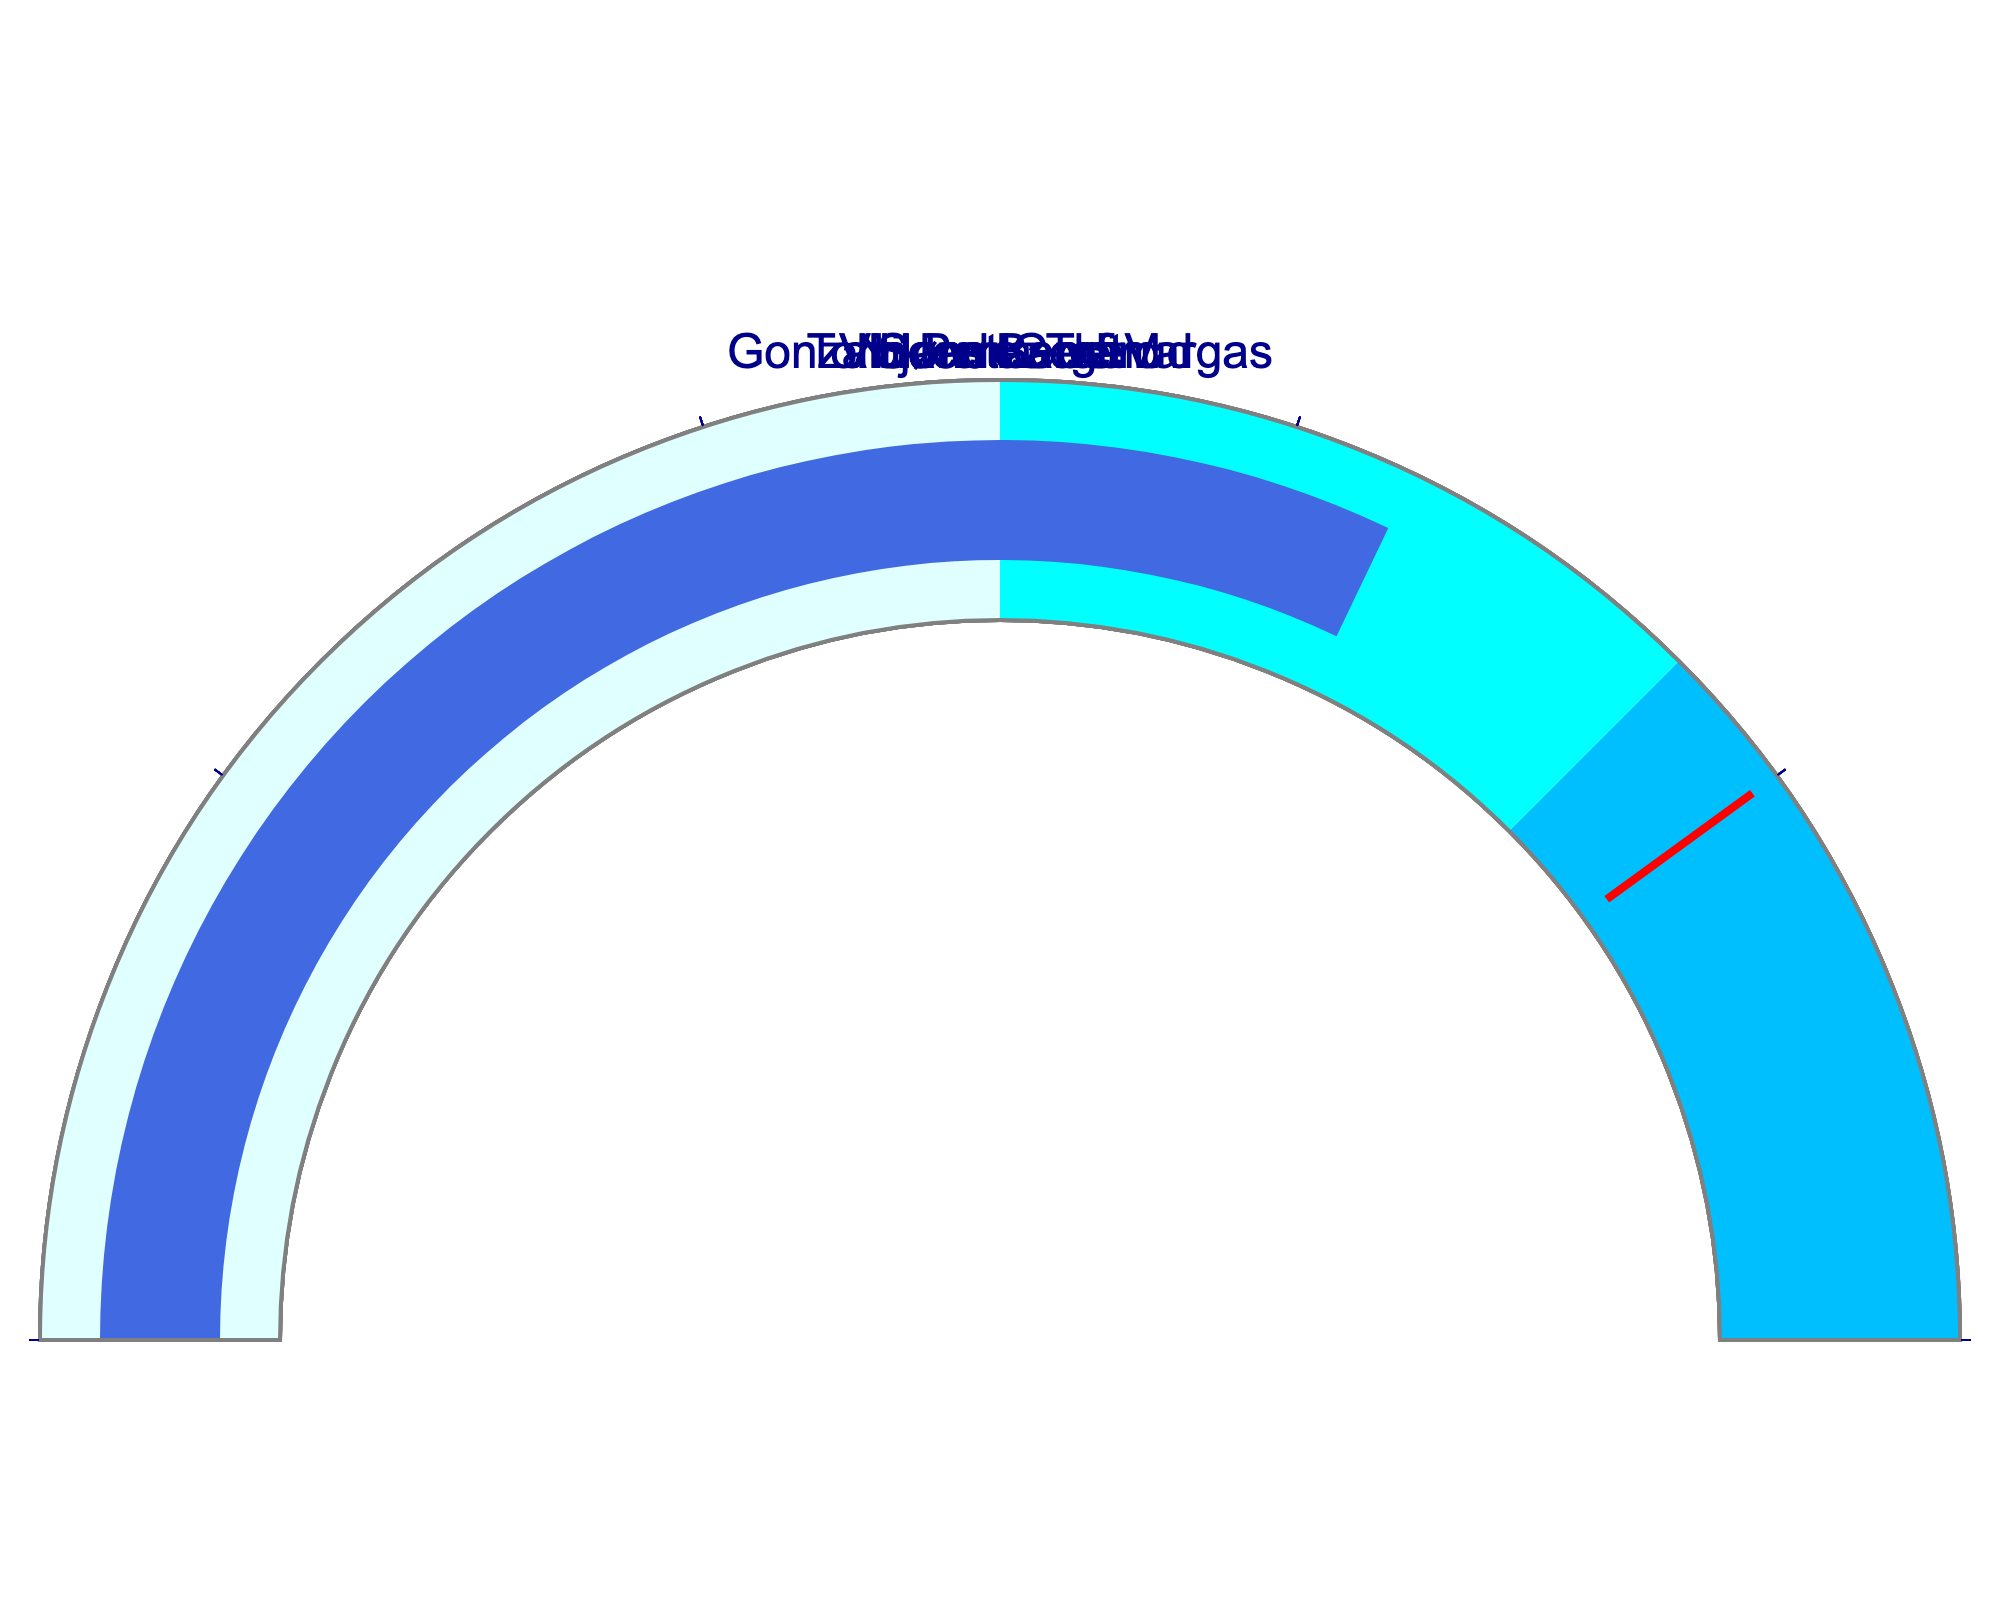Which goalkeeper has the highest save efficiency? By visually inspecting the gauge chart, locate the goalkeeper with the highest numerical value on their gauge.
Answer: Niklas Landin What is the save efficiency of the goalkeeper with the lowest number? By checking each gauge value, identify the lowest value, which is for Torbjørn Bergerud's gauge.
Answer: 64.2 How many goalkeepers have a save efficiency above 65.0? By reviewing each gauge, count the number of goalkeepers where the value exceeds 65.0.
Answer: 4 Who has a higher save efficiency, Sandra Toft or Vincent Gerard? Compare the numerical values on the gauges for Sandra Toft and Vincent Gerard. Sandra Toft has 69.8, while Vincent Gerard has 65.9.
Answer: Sandra Toft Which range of colors on the gauges indicates the highest efficiency? Inspect the legend of color ranges on the gauge charts. The highest efficiency is indicated by the color 'deepskyblue,' which covers the range from 75 to 100.
Answer: deepskyblue What is the average save efficiency of all five goalkeepers? Sum the save efficiencies: 72.5 + 69.8 + 67.3 + 65.9 + 64.2 = 339.7. Then, divide by the number of goalkeepers, which is 5.
Answer: 67.94 Which two goalkeepers have the closest save efficiency values? Compare each pair of numerical values to determine which two are closest. 65.9 (Vincent Gerard) and 64.2 (Torbjørn Bergerud) are the closest.
Answer: Vincent Gerard & Torbjørn Bergerud How far is Niklas Landin's save efficiency from the threshold value of 80? Subtract Niklas Landin's save efficiency from the threshold value of 80: 80 - 72.5 = 7.5.
Answer: 7.5 Who has the second-highest save efficiency? Exclude the highest value (Niklas Landin), then determine the second highest by visual inspection of the remaining gauges.
Answer: Sandra Toft 